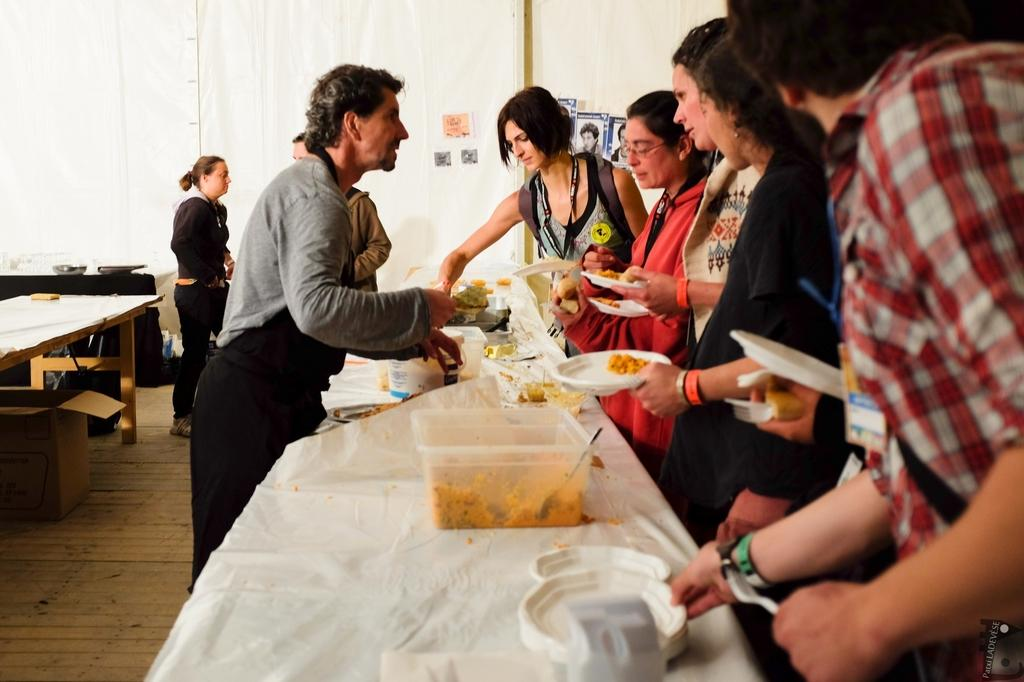How many people are in the image? There is a group of people in the image, but the exact number cannot be determined from the provided facts. What are the people doing in the image? The people are standing in front of a table. What can be seen on the table in the image? There are food items on the table. What type of instrument is the robin playing in the image? There is no robin or instrument present in the image. 